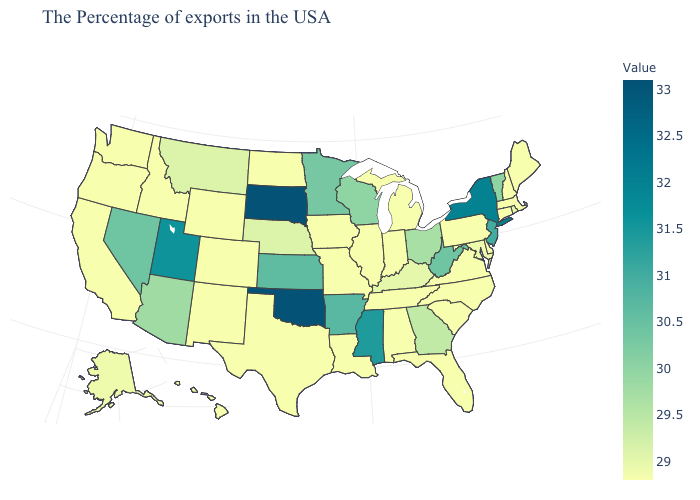Among the states that border New York , which have the lowest value?
Short answer required. Massachusetts, Connecticut, Pennsylvania. Among the states that border Alabama , does Mississippi have the highest value?
Be succinct. Yes. Which states hav the highest value in the West?
Concise answer only. Utah. 